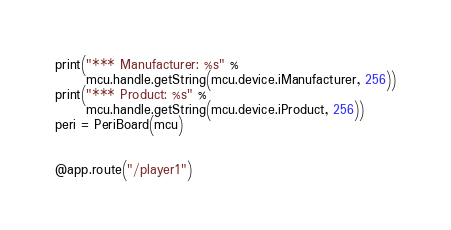Convert code to text. <code><loc_0><loc_0><loc_500><loc_500><_Python_>print("*** Manufacturer: %s" %
      mcu.handle.getString(mcu.device.iManufacturer, 256))
print("*** Product: %s" %
      mcu.handle.getString(mcu.device.iProduct, 256))
peri = PeriBoard(mcu)


@app.route("/player1")</code> 